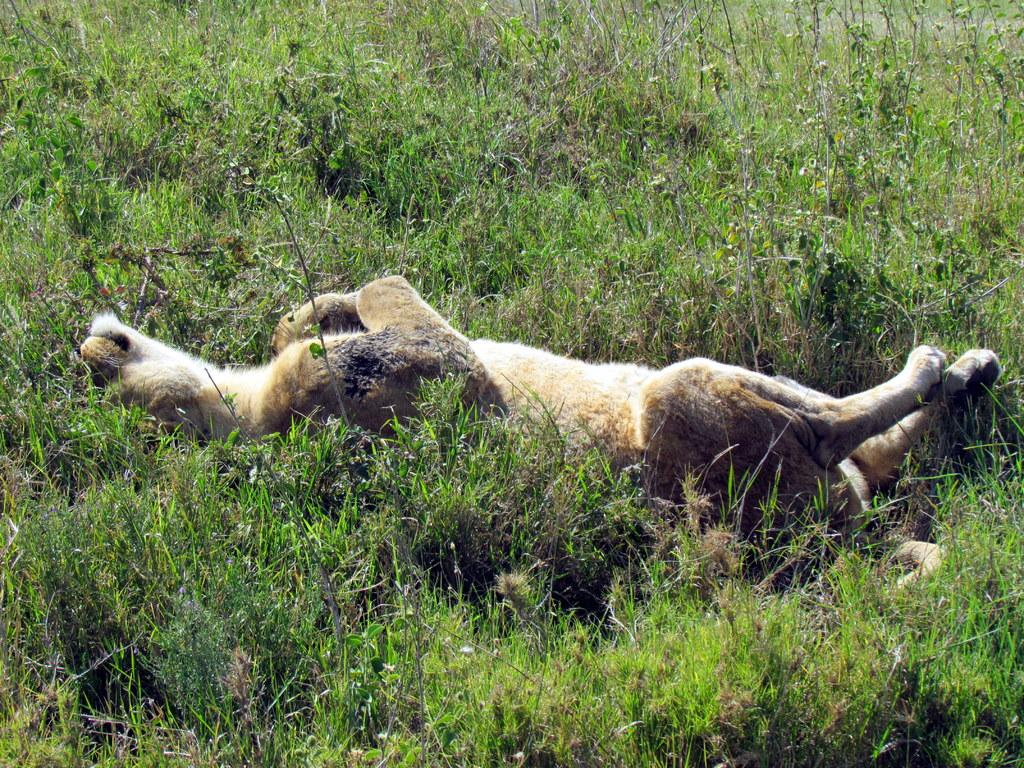What is the main subject of the image? The main subject of the image is a deceased animal. Where is the deceased animal located in the image? The deceased animal is on the ground. What type of vegetation can be seen in the image? There is grass visible in the image. What color is the coat of the animal in the image? There is no coat present in the image, as the animal is deceased. 